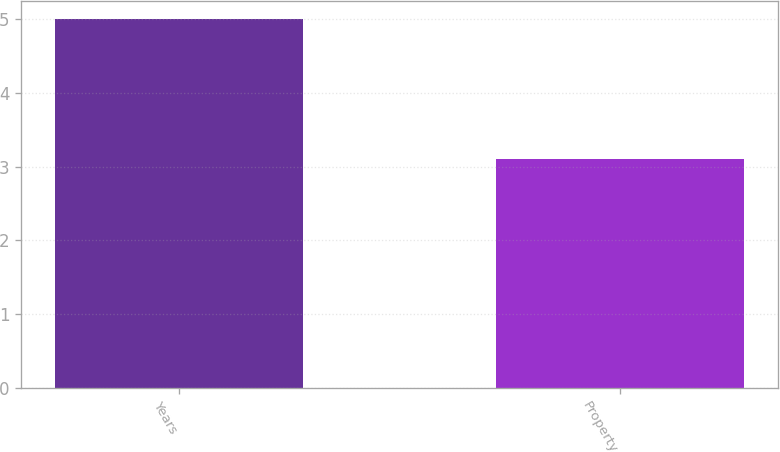<chart> <loc_0><loc_0><loc_500><loc_500><bar_chart><fcel>Years<fcel>Property<nl><fcel>5<fcel>3.1<nl></chart> 